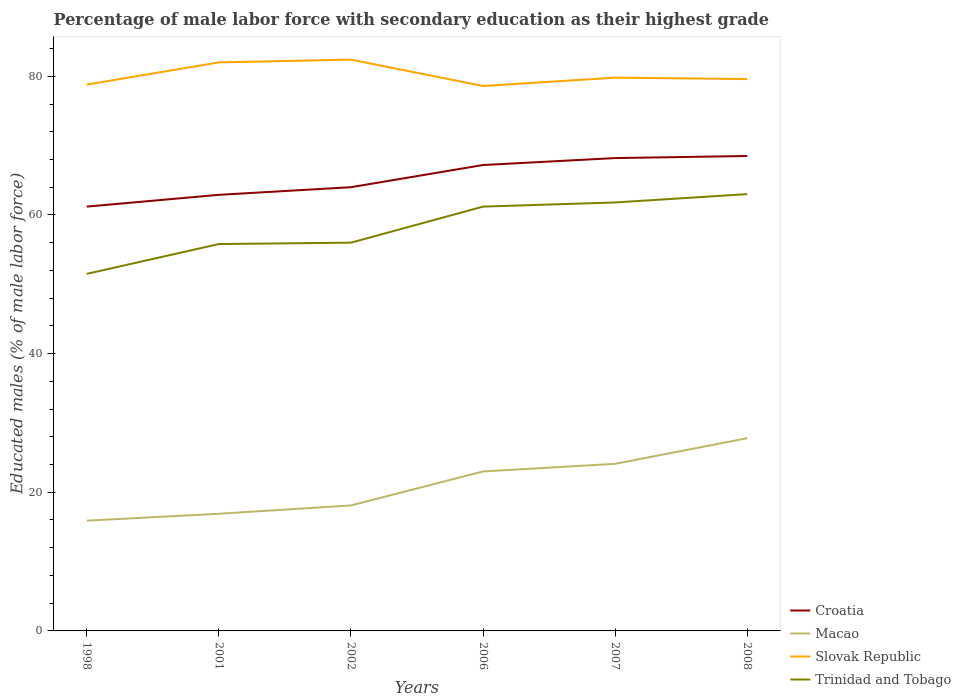Is the number of lines equal to the number of legend labels?
Provide a short and direct response. Yes. Across all years, what is the maximum percentage of male labor force with secondary education in Croatia?
Your answer should be very brief. 61.2. In which year was the percentage of male labor force with secondary education in Croatia maximum?
Your response must be concise. 1998. What is the total percentage of male labor force with secondary education in Slovak Republic in the graph?
Your answer should be compact. -0.4. Are the values on the major ticks of Y-axis written in scientific E-notation?
Keep it short and to the point. No. How many legend labels are there?
Provide a short and direct response. 4. What is the title of the graph?
Your response must be concise. Percentage of male labor force with secondary education as their highest grade. What is the label or title of the X-axis?
Make the answer very short. Years. What is the label or title of the Y-axis?
Keep it short and to the point. Educated males (% of male labor force). What is the Educated males (% of male labor force) in Croatia in 1998?
Your answer should be very brief. 61.2. What is the Educated males (% of male labor force) in Macao in 1998?
Ensure brevity in your answer.  15.9. What is the Educated males (% of male labor force) of Slovak Republic in 1998?
Offer a very short reply. 78.8. What is the Educated males (% of male labor force) in Trinidad and Tobago in 1998?
Your answer should be compact. 51.5. What is the Educated males (% of male labor force) in Croatia in 2001?
Your answer should be compact. 62.9. What is the Educated males (% of male labor force) of Macao in 2001?
Ensure brevity in your answer.  16.9. What is the Educated males (% of male labor force) in Slovak Republic in 2001?
Make the answer very short. 82. What is the Educated males (% of male labor force) of Trinidad and Tobago in 2001?
Offer a very short reply. 55.8. What is the Educated males (% of male labor force) in Macao in 2002?
Offer a terse response. 18.1. What is the Educated males (% of male labor force) of Slovak Republic in 2002?
Your answer should be compact. 82.4. What is the Educated males (% of male labor force) in Croatia in 2006?
Your response must be concise. 67.2. What is the Educated males (% of male labor force) in Slovak Republic in 2006?
Make the answer very short. 78.6. What is the Educated males (% of male labor force) of Trinidad and Tobago in 2006?
Provide a short and direct response. 61.2. What is the Educated males (% of male labor force) in Croatia in 2007?
Provide a succinct answer. 68.2. What is the Educated males (% of male labor force) of Macao in 2007?
Give a very brief answer. 24.1. What is the Educated males (% of male labor force) in Slovak Republic in 2007?
Provide a short and direct response. 79.8. What is the Educated males (% of male labor force) of Trinidad and Tobago in 2007?
Make the answer very short. 61.8. What is the Educated males (% of male labor force) in Croatia in 2008?
Make the answer very short. 68.5. What is the Educated males (% of male labor force) of Macao in 2008?
Make the answer very short. 27.8. What is the Educated males (% of male labor force) of Slovak Republic in 2008?
Offer a terse response. 79.6. Across all years, what is the maximum Educated males (% of male labor force) of Croatia?
Your answer should be very brief. 68.5. Across all years, what is the maximum Educated males (% of male labor force) of Macao?
Your answer should be very brief. 27.8. Across all years, what is the maximum Educated males (% of male labor force) of Slovak Republic?
Ensure brevity in your answer.  82.4. Across all years, what is the minimum Educated males (% of male labor force) in Croatia?
Make the answer very short. 61.2. Across all years, what is the minimum Educated males (% of male labor force) in Macao?
Ensure brevity in your answer.  15.9. Across all years, what is the minimum Educated males (% of male labor force) of Slovak Republic?
Give a very brief answer. 78.6. Across all years, what is the minimum Educated males (% of male labor force) of Trinidad and Tobago?
Your response must be concise. 51.5. What is the total Educated males (% of male labor force) of Croatia in the graph?
Provide a short and direct response. 392. What is the total Educated males (% of male labor force) in Macao in the graph?
Your answer should be compact. 125.8. What is the total Educated males (% of male labor force) in Slovak Republic in the graph?
Your response must be concise. 481.2. What is the total Educated males (% of male labor force) in Trinidad and Tobago in the graph?
Keep it short and to the point. 349.3. What is the difference between the Educated males (% of male labor force) of Trinidad and Tobago in 1998 and that in 2001?
Provide a short and direct response. -4.3. What is the difference between the Educated males (% of male labor force) of Croatia in 1998 and that in 2002?
Ensure brevity in your answer.  -2.8. What is the difference between the Educated males (% of male labor force) of Trinidad and Tobago in 1998 and that in 2002?
Provide a succinct answer. -4.5. What is the difference between the Educated males (% of male labor force) in Macao in 1998 and that in 2006?
Make the answer very short. -7.1. What is the difference between the Educated males (% of male labor force) of Trinidad and Tobago in 1998 and that in 2006?
Offer a very short reply. -9.7. What is the difference between the Educated males (% of male labor force) of Macao in 1998 and that in 2007?
Keep it short and to the point. -8.2. What is the difference between the Educated males (% of male labor force) of Trinidad and Tobago in 1998 and that in 2007?
Your response must be concise. -10.3. What is the difference between the Educated males (% of male labor force) in Slovak Republic in 1998 and that in 2008?
Keep it short and to the point. -0.8. What is the difference between the Educated males (% of male labor force) of Croatia in 2001 and that in 2002?
Your response must be concise. -1.1. What is the difference between the Educated males (% of male labor force) of Croatia in 2001 and that in 2006?
Offer a terse response. -4.3. What is the difference between the Educated males (% of male labor force) of Macao in 2001 and that in 2006?
Keep it short and to the point. -6.1. What is the difference between the Educated males (% of male labor force) in Croatia in 2001 and that in 2007?
Your answer should be compact. -5.3. What is the difference between the Educated males (% of male labor force) in Slovak Republic in 2001 and that in 2007?
Provide a short and direct response. 2.2. What is the difference between the Educated males (% of male labor force) in Macao in 2002 and that in 2006?
Provide a short and direct response. -4.9. What is the difference between the Educated males (% of male labor force) in Trinidad and Tobago in 2002 and that in 2006?
Your response must be concise. -5.2. What is the difference between the Educated males (% of male labor force) of Croatia in 2002 and that in 2008?
Give a very brief answer. -4.5. What is the difference between the Educated males (% of male labor force) in Slovak Republic in 2002 and that in 2008?
Keep it short and to the point. 2.8. What is the difference between the Educated males (% of male labor force) in Slovak Republic in 2006 and that in 2007?
Provide a succinct answer. -1.2. What is the difference between the Educated males (% of male labor force) of Trinidad and Tobago in 2006 and that in 2007?
Your answer should be very brief. -0.6. What is the difference between the Educated males (% of male labor force) in Trinidad and Tobago in 2006 and that in 2008?
Keep it short and to the point. -1.8. What is the difference between the Educated males (% of male labor force) of Croatia in 1998 and the Educated males (% of male labor force) of Macao in 2001?
Give a very brief answer. 44.3. What is the difference between the Educated males (% of male labor force) in Croatia in 1998 and the Educated males (% of male labor force) in Slovak Republic in 2001?
Provide a short and direct response. -20.8. What is the difference between the Educated males (% of male labor force) in Croatia in 1998 and the Educated males (% of male labor force) in Trinidad and Tobago in 2001?
Ensure brevity in your answer.  5.4. What is the difference between the Educated males (% of male labor force) of Macao in 1998 and the Educated males (% of male labor force) of Slovak Republic in 2001?
Your answer should be compact. -66.1. What is the difference between the Educated males (% of male labor force) in Macao in 1998 and the Educated males (% of male labor force) in Trinidad and Tobago in 2001?
Offer a very short reply. -39.9. What is the difference between the Educated males (% of male labor force) of Croatia in 1998 and the Educated males (% of male labor force) of Macao in 2002?
Ensure brevity in your answer.  43.1. What is the difference between the Educated males (% of male labor force) in Croatia in 1998 and the Educated males (% of male labor force) in Slovak Republic in 2002?
Your answer should be compact. -21.2. What is the difference between the Educated males (% of male labor force) of Macao in 1998 and the Educated males (% of male labor force) of Slovak Republic in 2002?
Your answer should be compact. -66.5. What is the difference between the Educated males (% of male labor force) in Macao in 1998 and the Educated males (% of male labor force) in Trinidad and Tobago in 2002?
Keep it short and to the point. -40.1. What is the difference between the Educated males (% of male labor force) of Slovak Republic in 1998 and the Educated males (% of male labor force) of Trinidad and Tobago in 2002?
Provide a succinct answer. 22.8. What is the difference between the Educated males (% of male labor force) of Croatia in 1998 and the Educated males (% of male labor force) of Macao in 2006?
Provide a succinct answer. 38.2. What is the difference between the Educated males (% of male labor force) of Croatia in 1998 and the Educated males (% of male labor force) of Slovak Republic in 2006?
Give a very brief answer. -17.4. What is the difference between the Educated males (% of male labor force) in Croatia in 1998 and the Educated males (% of male labor force) in Trinidad and Tobago in 2006?
Offer a terse response. 0. What is the difference between the Educated males (% of male labor force) of Macao in 1998 and the Educated males (% of male labor force) of Slovak Republic in 2006?
Keep it short and to the point. -62.7. What is the difference between the Educated males (% of male labor force) in Macao in 1998 and the Educated males (% of male labor force) in Trinidad and Tobago in 2006?
Provide a short and direct response. -45.3. What is the difference between the Educated males (% of male labor force) of Croatia in 1998 and the Educated males (% of male labor force) of Macao in 2007?
Offer a terse response. 37.1. What is the difference between the Educated males (% of male labor force) in Croatia in 1998 and the Educated males (% of male labor force) in Slovak Republic in 2007?
Offer a very short reply. -18.6. What is the difference between the Educated males (% of male labor force) in Croatia in 1998 and the Educated males (% of male labor force) in Trinidad and Tobago in 2007?
Ensure brevity in your answer.  -0.6. What is the difference between the Educated males (% of male labor force) of Macao in 1998 and the Educated males (% of male labor force) of Slovak Republic in 2007?
Offer a very short reply. -63.9. What is the difference between the Educated males (% of male labor force) of Macao in 1998 and the Educated males (% of male labor force) of Trinidad and Tobago in 2007?
Ensure brevity in your answer.  -45.9. What is the difference between the Educated males (% of male labor force) in Slovak Republic in 1998 and the Educated males (% of male labor force) in Trinidad and Tobago in 2007?
Offer a very short reply. 17. What is the difference between the Educated males (% of male labor force) of Croatia in 1998 and the Educated males (% of male labor force) of Macao in 2008?
Offer a terse response. 33.4. What is the difference between the Educated males (% of male labor force) in Croatia in 1998 and the Educated males (% of male labor force) in Slovak Republic in 2008?
Your answer should be compact. -18.4. What is the difference between the Educated males (% of male labor force) of Macao in 1998 and the Educated males (% of male labor force) of Slovak Republic in 2008?
Your answer should be very brief. -63.7. What is the difference between the Educated males (% of male labor force) in Macao in 1998 and the Educated males (% of male labor force) in Trinidad and Tobago in 2008?
Ensure brevity in your answer.  -47.1. What is the difference between the Educated males (% of male labor force) of Croatia in 2001 and the Educated males (% of male labor force) of Macao in 2002?
Provide a short and direct response. 44.8. What is the difference between the Educated males (% of male labor force) of Croatia in 2001 and the Educated males (% of male labor force) of Slovak Republic in 2002?
Keep it short and to the point. -19.5. What is the difference between the Educated males (% of male labor force) of Macao in 2001 and the Educated males (% of male labor force) of Slovak Republic in 2002?
Give a very brief answer. -65.5. What is the difference between the Educated males (% of male labor force) in Macao in 2001 and the Educated males (% of male labor force) in Trinidad and Tobago in 2002?
Give a very brief answer. -39.1. What is the difference between the Educated males (% of male labor force) of Slovak Republic in 2001 and the Educated males (% of male labor force) of Trinidad and Tobago in 2002?
Your answer should be compact. 26. What is the difference between the Educated males (% of male labor force) of Croatia in 2001 and the Educated males (% of male labor force) of Macao in 2006?
Your answer should be compact. 39.9. What is the difference between the Educated males (% of male labor force) of Croatia in 2001 and the Educated males (% of male labor force) of Slovak Republic in 2006?
Make the answer very short. -15.7. What is the difference between the Educated males (% of male labor force) of Croatia in 2001 and the Educated males (% of male labor force) of Trinidad and Tobago in 2006?
Provide a short and direct response. 1.7. What is the difference between the Educated males (% of male labor force) of Macao in 2001 and the Educated males (% of male labor force) of Slovak Republic in 2006?
Offer a terse response. -61.7. What is the difference between the Educated males (% of male labor force) in Macao in 2001 and the Educated males (% of male labor force) in Trinidad and Tobago in 2006?
Make the answer very short. -44.3. What is the difference between the Educated males (% of male labor force) in Slovak Republic in 2001 and the Educated males (% of male labor force) in Trinidad and Tobago in 2006?
Give a very brief answer. 20.8. What is the difference between the Educated males (% of male labor force) of Croatia in 2001 and the Educated males (% of male labor force) of Macao in 2007?
Your response must be concise. 38.8. What is the difference between the Educated males (% of male labor force) of Croatia in 2001 and the Educated males (% of male labor force) of Slovak Republic in 2007?
Ensure brevity in your answer.  -16.9. What is the difference between the Educated males (% of male labor force) of Macao in 2001 and the Educated males (% of male labor force) of Slovak Republic in 2007?
Make the answer very short. -62.9. What is the difference between the Educated males (% of male labor force) in Macao in 2001 and the Educated males (% of male labor force) in Trinidad and Tobago in 2007?
Provide a succinct answer. -44.9. What is the difference between the Educated males (% of male labor force) of Slovak Republic in 2001 and the Educated males (% of male labor force) of Trinidad and Tobago in 2007?
Give a very brief answer. 20.2. What is the difference between the Educated males (% of male labor force) of Croatia in 2001 and the Educated males (% of male labor force) of Macao in 2008?
Offer a terse response. 35.1. What is the difference between the Educated males (% of male labor force) in Croatia in 2001 and the Educated males (% of male labor force) in Slovak Republic in 2008?
Give a very brief answer. -16.7. What is the difference between the Educated males (% of male labor force) in Macao in 2001 and the Educated males (% of male labor force) in Slovak Republic in 2008?
Give a very brief answer. -62.7. What is the difference between the Educated males (% of male labor force) of Macao in 2001 and the Educated males (% of male labor force) of Trinidad and Tobago in 2008?
Your answer should be compact. -46.1. What is the difference between the Educated males (% of male labor force) of Croatia in 2002 and the Educated males (% of male labor force) of Macao in 2006?
Provide a succinct answer. 41. What is the difference between the Educated males (% of male labor force) in Croatia in 2002 and the Educated males (% of male labor force) in Slovak Republic in 2006?
Your response must be concise. -14.6. What is the difference between the Educated males (% of male labor force) of Croatia in 2002 and the Educated males (% of male labor force) of Trinidad and Tobago in 2006?
Ensure brevity in your answer.  2.8. What is the difference between the Educated males (% of male labor force) in Macao in 2002 and the Educated males (% of male labor force) in Slovak Republic in 2006?
Your answer should be compact. -60.5. What is the difference between the Educated males (% of male labor force) in Macao in 2002 and the Educated males (% of male labor force) in Trinidad and Tobago in 2006?
Keep it short and to the point. -43.1. What is the difference between the Educated males (% of male labor force) in Slovak Republic in 2002 and the Educated males (% of male labor force) in Trinidad and Tobago in 2006?
Your response must be concise. 21.2. What is the difference between the Educated males (% of male labor force) of Croatia in 2002 and the Educated males (% of male labor force) of Macao in 2007?
Make the answer very short. 39.9. What is the difference between the Educated males (% of male labor force) in Croatia in 2002 and the Educated males (% of male labor force) in Slovak Republic in 2007?
Offer a terse response. -15.8. What is the difference between the Educated males (% of male labor force) of Macao in 2002 and the Educated males (% of male labor force) of Slovak Republic in 2007?
Keep it short and to the point. -61.7. What is the difference between the Educated males (% of male labor force) of Macao in 2002 and the Educated males (% of male labor force) of Trinidad and Tobago in 2007?
Make the answer very short. -43.7. What is the difference between the Educated males (% of male labor force) of Slovak Republic in 2002 and the Educated males (% of male labor force) of Trinidad and Tobago in 2007?
Your response must be concise. 20.6. What is the difference between the Educated males (% of male labor force) in Croatia in 2002 and the Educated males (% of male labor force) in Macao in 2008?
Your answer should be very brief. 36.2. What is the difference between the Educated males (% of male labor force) in Croatia in 2002 and the Educated males (% of male labor force) in Slovak Republic in 2008?
Your answer should be compact. -15.6. What is the difference between the Educated males (% of male labor force) in Croatia in 2002 and the Educated males (% of male labor force) in Trinidad and Tobago in 2008?
Provide a succinct answer. 1. What is the difference between the Educated males (% of male labor force) of Macao in 2002 and the Educated males (% of male labor force) of Slovak Republic in 2008?
Your response must be concise. -61.5. What is the difference between the Educated males (% of male labor force) in Macao in 2002 and the Educated males (% of male labor force) in Trinidad and Tobago in 2008?
Keep it short and to the point. -44.9. What is the difference between the Educated males (% of male labor force) of Slovak Republic in 2002 and the Educated males (% of male labor force) of Trinidad and Tobago in 2008?
Offer a very short reply. 19.4. What is the difference between the Educated males (% of male labor force) of Croatia in 2006 and the Educated males (% of male labor force) of Macao in 2007?
Ensure brevity in your answer.  43.1. What is the difference between the Educated males (% of male labor force) in Croatia in 2006 and the Educated males (% of male labor force) in Slovak Republic in 2007?
Offer a terse response. -12.6. What is the difference between the Educated males (% of male labor force) in Croatia in 2006 and the Educated males (% of male labor force) in Trinidad and Tobago in 2007?
Give a very brief answer. 5.4. What is the difference between the Educated males (% of male labor force) of Macao in 2006 and the Educated males (% of male labor force) of Slovak Republic in 2007?
Your response must be concise. -56.8. What is the difference between the Educated males (% of male labor force) of Macao in 2006 and the Educated males (% of male labor force) of Trinidad and Tobago in 2007?
Ensure brevity in your answer.  -38.8. What is the difference between the Educated males (% of male labor force) of Slovak Republic in 2006 and the Educated males (% of male labor force) of Trinidad and Tobago in 2007?
Offer a very short reply. 16.8. What is the difference between the Educated males (% of male labor force) in Croatia in 2006 and the Educated males (% of male labor force) in Macao in 2008?
Your answer should be compact. 39.4. What is the difference between the Educated males (% of male labor force) in Croatia in 2006 and the Educated males (% of male labor force) in Trinidad and Tobago in 2008?
Keep it short and to the point. 4.2. What is the difference between the Educated males (% of male labor force) of Macao in 2006 and the Educated males (% of male labor force) of Slovak Republic in 2008?
Your answer should be compact. -56.6. What is the difference between the Educated males (% of male labor force) in Macao in 2006 and the Educated males (% of male labor force) in Trinidad and Tobago in 2008?
Provide a short and direct response. -40. What is the difference between the Educated males (% of male labor force) in Slovak Republic in 2006 and the Educated males (% of male labor force) in Trinidad and Tobago in 2008?
Make the answer very short. 15.6. What is the difference between the Educated males (% of male labor force) in Croatia in 2007 and the Educated males (% of male labor force) in Macao in 2008?
Ensure brevity in your answer.  40.4. What is the difference between the Educated males (% of male labor force) of Macao in 2007 and the Educated males (% of male labor force) of Slovak Republic in 2008?
Keep it short and to the point. -55.5. What is the difference between the Educated males (% of male labor force) in Macao in 2007 and the Educated males (% of male labor force) in Trinidad and Tobago in 2008?
Provide a short and direct response. -38.9. What is the average Educated males (% of male labor force) in Croatia per year?
Provide a short and direct response. 65.33. What is the average Educated males (% of male labor force) in Macao per year?
Offer a terse response. 20.97. What is the average Educated males (% of male labor force) in Slovak Republic per year?
Keep it short and to the point. 80.2. What is the average Educated males (% of male labor force) in Trinidad and Tobago per year?
Ensure brevity in your answer.  58.22. In the year 1998, what is the difference between the Educated males (% of male labor force) in Croatia and Educated males (% of male labor force) in Macao?
Ensure brevity in your answer.  45.3. In the year 1998, what is the difference between the Educated males (% of male labor force) in Croatia and Educated males (% of male labor force) in Slovak Republic?
Your answer should be compact. -17.6. In the year 1998, what is the difference between the Educated males (% of male labor force) in Macao and Educated males (% of male labor force) in Slovak Republic?
Your answer should be very brief. -62.9. In the year 1998, what is the difference between the Educated males (% of male labor force) in Macao and Educated males (% of male labor force) in Trinidad and Tobago?
Give a very brief answer. -35.6. In the year 1998, what is the difference between the Educated males (% of male labor force) of Slovak Republic and Educated males (% of male labor force) of Trinidad and Tobago?
Give a very brief answer. 27.3. In the year 2001, what is the difference between the Educated males (% of male labor force) of Croatia and Educated males (% of male labor force) of Macao?
Ensure brevity in your answer.  46. In the year 2001, what is the difference between the Educated males (% of male labor force) of Croatia and Educated males (% of male labor force) of Slovak Republic?
Offer a terse response. -19.1. In the year 2001, what is the difference between the Educated males (% of male labor force) of Macao and Educated males (% of male labor force) of Slovak Republic?
Keep it short and to the point. -65.1. In the year 2001, what is the difference between the Educated males (% of male labor force) in Macao and Educated males (% of male labor force) in Trinidad and Tobago?
Your answer should be very brief. -38.9. In the year 2001, what is the difference between the Educated males (% of male labor force) in Slovak Republic and Educated males (% of male labor force) in Trinidad and Tobago?
Provide a short and direct response. 26.2. In the year 2002, what is the difference between the Educated males (% of male labor force) of Croatia and Educated males (% of male labor force) of Macao?
Provide a short and direct response. 45.9. In the year 2002, what is the difference between the Educated males (% of male labor force) of Croatia and Educated males (% of male labor force) of Slovak Republic?
Your answer should be very brief. -18.4. In the year 2002, what is the difference between the Educated males (% of male labor force) of Croatia and Educated males (% of male labor force) of Trinidad and Tobago?
Offer a very short reply. 8. In the year 2002, what is the difference between the Educated males (% of male labor force) of Macao and Educated males (% of male labor force) of Slovak Republic?
Keep it short and to the point. -64.3. In the year 2002, what is the difference between the Educated males (% of male labor force) in Macao and Educated males (% of male labor force) in Trinidad and Tobago?
Offer a terse response. -37.9. In the year 2002, what is the difference between the Educated males (% of male labor force) in Slovak Republic and Educated males (% of male labor force) in Trinidad and Tobago?
Ensure brevity in your answer.  26.4. In the year 2006, what is the difference between the Educated males (% of male labor force) of Croatia and Educated males (% of male labor force) of Macao?
Offer a very short reply. 44.2. In the year 2006, what is the difference between the Educated males (% of male labor force) of Croatia and Educated males (% of male labor force) of Slovak Republic?
Offer a terse response. -11.4. In the year 2006, what is the difference between the Educated males (% of male labor force) in Macao and Educated males (% of male labor force) in Slovak Republic?
Your answer should be compact. -55.6. In the year 2006, what is the difference between the Educated males (% of male labor force) in Macao and Educated males (% of male labor force) in Trinidad and Tobago?
Provide a succinct answer. -38.2. In the year 2007, what is the difference between the Educated males (% of male labor force) in Croatia and Educated males (% of male labor force) in Macao?
Your answer should be compact. 44.1. In the year 2007, what is the difference between the Educated males (% of male labor force) of Croatia and Educated males (% of male labor force) of Slovak Republic?
Offer a terse response. -11.6. In the year 2007, what is the difference between the Educated males (% of male labor force) in Croatia and Educated males (% of male labor force) in Trinidad and Tobago?
Provide a short and direct response. 6.4. In the year 2007, what is the difference between the Educated males (% of male labor force) in Macao and Educated males (% of male labor force) in Slovak Republic?
Ensure brevity in your answer.  -55.7. In the year 2007, what is the difference between the Educated males (% of male labor force) of Macao and Educated males (% of male labor force) of Trinidad and Tobago?
Offer a very short reply. -37.7. In the year 2007, what is the difference between the Educated males (% of male labor force) in Slovak Republic and Educated males (% of male labor force) in Trinidad and Tobago?
Your answer should be very brief. 18. In the year 2008, what is the difference between the Educated males (% of male labor force) of Croatia and Educated males (% of male labor force) of Macao?
Give a very brief answer. 40.7. In the year 2008, what is the difference between the Educated males (% of male labor force) of Croatia and Educated males (% of male labor force) of Slovak Republic?
Your answer should be compact. -11.1. In the year 2008, what is the difference between the Educated males (% of male labor force) of Macao and Educated males (% of male labor force) of Slovak Republic?
Make the answer very short. -51.8. In the year 2008, what is the difference between the Educated males (% of male labor force) of Macao and Educated males (% of male labor force) of Trinidad and Tobago?
Offer a very short reply. -35.2. In the year 2008, what is the difference between the Educated males (% of male labor force) of Slovak Republic and Educated males (% of male labor force) of Trinidad and Tobago?
Provide a short and direct response. 16.6. What is the ratio of the Educated males (% of male labor force) of Croatia in 1998 to that in 2001?
Provide a succinct answer. 0.97. What is the ratio of the Educated males (% of male labor force) of Macao in 1998 to that in 2001?
Your answer should be compact. 0.94. What is the ratio of the Educated males (% of male labor force) of Trinidad and Tobago in 1998 to that in 2001?
Give a very brief answer. 0.92. What is the ratio of the Educated males (% of male labor force) in Croatia in 1998 to that in 2002?
Your response must be concise. 0.96. What is the ratio of the Educated males (% of male labor force) of Macao in 1998 to that in 2002?
Your response must be concise. 0.88. What is the ratio of the Educated males (% of male labor force) of Slovak Republic in 1998 to that in 2002?
Offer a very short reply. 0.96. What is the ratio of the Educated males (% of male labor force) of Trinidad and Tobago in 1998 to that in 2002?
Ensure brevity in your answer.  0.92. What is the ratio of the Educated males (% of male labor force) of Croatia in 1998 to that in 2006?
Give a very brief answer. 0.91. What is the ratio of the Educated males (% of male labor force) of Macao in 1998 to that in 2006?
Provide a succinct answer. 0.69. What is the ratio of the Educated males (% of male labor force) in Slovak Republic in 1998 to that in 2006?
Provide a succinct answer. 1. What is the ratio of the Educated males (% of male labor force) of Trinidad and Tobago in 1998 to that in 2006?
Keep it short and to the point. 0.84. What is the ratio of the Educated males (% of male labor force) of Croatia in 1998 to that in 2007?
Offer a terse response. 0.9. What is the ratio of the Educated males (% of male labor force) in Macao in 1998 to that in 2007?
Offer a terse response. 0.66. What is the ratio of the Educated males (% of male labor force) in Slovak Republic in 1998 to that in 2007?
Your answer should be very brief. 0.99. What is the ratio of the Educated males (% of male labor force) in Croatia in 1998 to that in 2008?
Your response must be concise. 0.89. What is the ratio of the Educated males (% of male labor force) in Macao in 1998 to that in 2008?
Your response must be concise. 0.57. What is the ratio of the Educated males (% of male labor force) in Slovak Republic in 1998 to that in 2008?
Provide a succinct answer. 0.99. What is the ratio of the Educated males (% of male labor force) of Trinidad and Tobago in 1998 to that in 2008?
Provide a short and direct response. 0.82. What is the ratio of the Educated males (% of male labor force) in Croatia in 2001 to that in 2002?
Keep it short and to the point. 0.98. What is the ratio of the Educated males (% of male labor force) of Macao in 2001 to that in 2002?
Offer a very short reply. 0.93. What is the ratio of the Educated males (% of male labor force) of Croatia in 2001 to that in 2006?
Your answer should be compact. 0.94. What is the ratio of the Educated males (% of male labor force) in Macao in 2001 to that in 2006?
Offer a terse response. 0.73. What is the ratio of the Educated males (% of male labor force) in Slovak Republic in 2001 to that in 2006?
Your response must be concise. 1.04. What is the ratio of the Educated males (% of male labor force) of Trinidad and Tobago in 2001 to that in 2006?
Give a very brief answer. 0.91. What is the ratio of the Educated males (% of male labor force) in Croatia in 2001 to that in 2007?
Provide a short and direct response. 0.92. What is the ratio of the Educated males (% of male labor force) in Macao in 2001 to that in 2007?
Provide a succinct answer. 0.7. What is the ratio of the Educated males (% of male labor force) in Slovak Republic in 2001 to that in 2007?
Provide a succinct answer. 1.03. What is the ratio of the Educated males (% of male labor force) in Trinidad and Tobago in 2001 to that in 2007?
Your answer should be compact. 0.9. What is the ratio of the Educated males (% of male labor force) of Croatia in 2001 to that in 2008?
Your answer should be very brief. 0.92. What is the ratio of the Educated males (% of male labor force) of Macao in 2001 to that in 2008?
Your answer should be very brief. 0.61. What is the ratio of the Educated males (% of male labor force) in Slovak Republic in 2001 to that in 2008?
Provide a short and direct response. 1.03. What is the ratio of the Educated males (% of male labor force) in Trinidad and Tobago in 2001 to that in 2008?
Offer a very short reply. 0.89. What is the ratio of the Educated males (% of male labor force) of Macao in 2002 to that in 2006?
Ensure brevity in your answer.  0.79. What is the ratio of the Educated males (% of male labor force) of Slovak Republic in 2002 to that in 2006?
Offer a very short reply. 1.05. What is the ratio of the Educated males (% of male labor force) of Trinidad and Tobago in 2002 to that in 2006?
Provide a short and direct response. 0.92. What is the ratio of the Educated males (% of male labor force) of Croatia in 2002 to that in 2007?
Your answer should be compact. 0.94. What is the ratio of the Educated males (% of male labor force) of Macao in 2002 to that in 2007?
Offer a terse response. 0.75. What is the ratio of the Educated males (% of male labor force) of Slovak Republic in 2002 to that in 2007?
Keep it short and to the point. 1.03. What is the ratio of the Educated males (% of male labor force) in Trinidad and Tobago in 2002 to that in 2007?
Provide a short and direct response. 0.91. What is the ratio of the Educated males (% of male labor force) of Croatia in 2002 to that in 2008?
Offer a very short reply. 0.93. What is the ratio of the Educated males (% of male labor force) in Macao in 2002 to that in 2008?
Provide a short and direct response. 0.65. What is the ratio of the Educated males (% of male labor force) in Slovak Republic in 2002 to that in 2008?
Your answer should be very brief. 1.04. What is the ratio of the Educated males (% of male labor force) in Trinidad and Tobago in 2002 to that in 2008?
Your answer should be very brief. 0.89. What is the ratio of the Educated males (% of male labor force) in Macao in 2006 to that in 2007?
Make the answer very short. 0.95. What is the ratio of the Educated males (% of male labor force) in Trinidad and Tobago in 2006 to that in 2007?
Your response must be concise. 0.99. What is the ratio of the Educated males (% of male labor force) of Croatia in 2006 to that in 2008?
Provide a short and direct response. 0.98. What is the ratio of the Educated males (% of male labor force) of Macao in 2006 to that in 2008?
Your answer should be very brief. 0.83. What is the ratio of the Educated males (% of male labor force) in Slovak Republic in 2006 to that in 2008?
Make the answer very short. 0.99. What is the ratio of the Educated males (% of male labor force) in Trinidad and Tobago in 2006 to that in 2008?
Keep it short and to the point. 0.97. What is the ratio of the Educated males (% of male labor force) in Croatia in 2007 to that in 2008?
Offer a very short reply. 1. What is the ratio of the Educated males (% of male labor force) of Macao in 2007 to that in 2008?
Your response must be concise. 0.87. What is the ratio of the Educated males (% of male labor force) of Slovak Republic in 2007 to that in 2008?
Offer a terse response. 1. What is the ratio of the Educated males (% of male labor force) in Trinidad and Tobago in 2007 to that in 2008?
Ensure brevity in your answer.  0.98. What is the difference between the highest and the second highest Educated males (% of male labor force) of Croatia?
Offer a terse response. 0.3. What is the difference between the highest and the lowest Educated males (% of male labor force) in Macao?
Ensure brevity in your answer.  11.9. What is the difference between the highest and the lowest Educated males (% of male labor force) in Slovak Republic?
Make the answer very short. 3.8. 